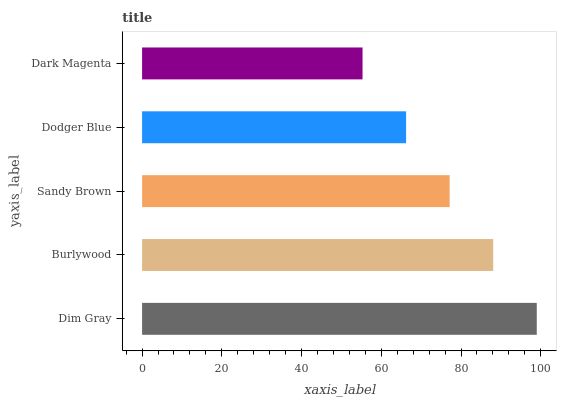Is Dark Magenta the minimum?
Answer yes or no. Yes. Is Dim Gray the maximum?
Answer yes or no. Yes. Is Burlywood the minimum?
Answer yes or no. No. Is Burlywood the maximum?
Answer yes or no. No. Is Dim Gray greater than Burlywood?
Answer yes or no. Yes. Is Burlywood less than Dim Gray?
Answer yes or no. Yes. Is Burlywood greater than Dim Gray?
Answer yes or no. No. Is Dim Gray less than Burlywood?
Answer yes or no. No. Is Sandy Brown the high median?
Answer yes or no. Yes. Is Sandy Brown the low median?
Answer yes or no. Yes. Is Dim Gray the high median?
Answer yes or no. No. Is Burlywood the low median?
Answer yes or no. No. 